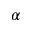<formula> <loc_0><loc_0><loc_500><loc_500>\alpha</formula> 